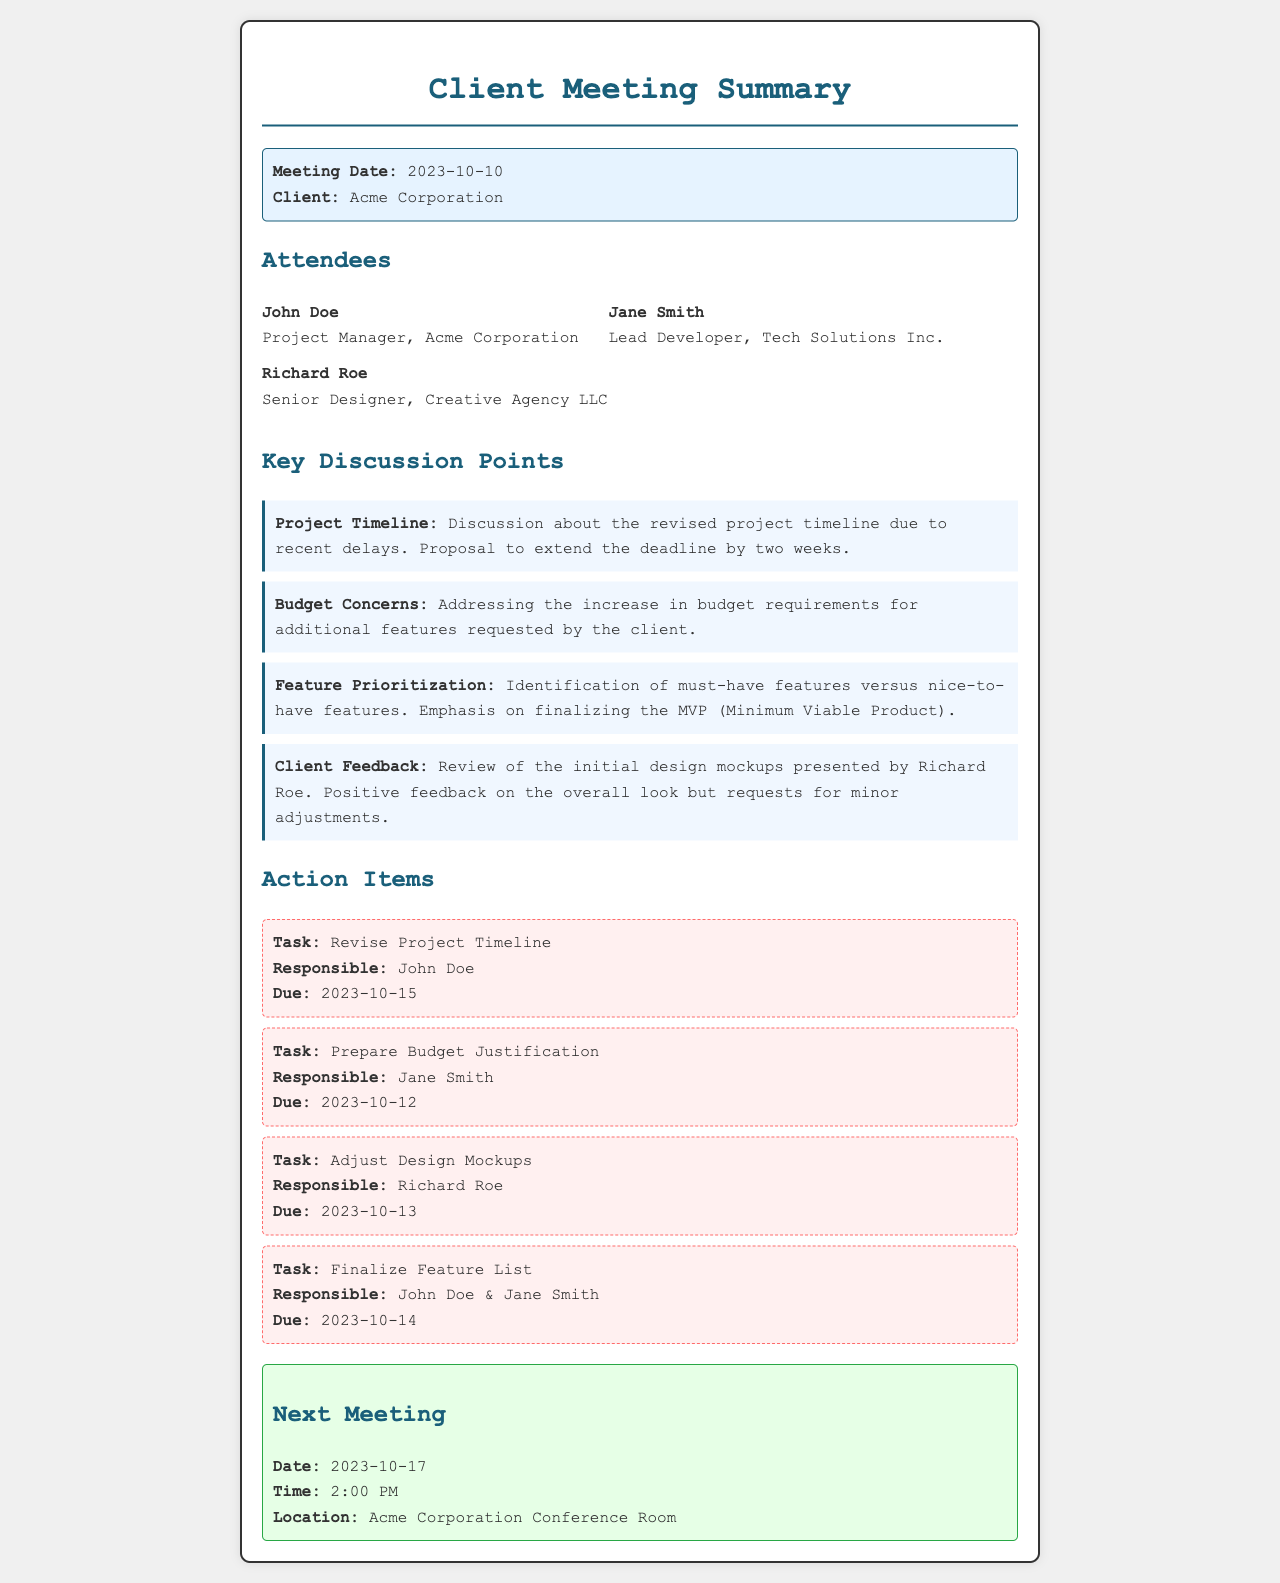What is the meeting date? The meeting date is specified in the document, which is listed as the date of the meeting.
Answer: 2023-10-10 Who is the Project Manager at Acme Corporation? The document lists John Doe as the Project Manager for Acme Corporation under the Attendees section.
Answer: John Doe What is one of the key discussion points? The document provides several key discussion points, allowing for multiple valid responses; one example can be derived from the topic titles.
Answer: Project Timeline What is the due date for revising the project timeline? The action items section specifies the due date for revising the project timeline assigned to John Doe.
Answer: 2023-10-15 Who is responsible for adjusting design mockups? Each action item includes a responsible party, allowing us to determine who is accountable for specific tasks.
Answer: Richard Roe What was the main feedback given by the client on the initial design? The document summarizes the client feedback regarding the design mockups, providing insight into client opinions.
Answer: Positive feedback What date is the next meeting scheduled? The next meeting date is explicitly indicated in the document, detailing when the follow-up meeting will occur.
Answer: 2023-10-17 Who needs to prepare the budget justification? The responsible party for preparing budget justification is listed in the action items section of the document.
Answer: Jane Smith Which attendees are responsible for finalizing the feature list? The document specifies which attendees are tasked with finalizing the feature list, indicating shared responsibility.
Answer: John Doe & Jane Smith 